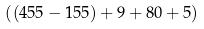<formula> <loc_0><loc_0><loc_500><loc_500>( ( 4 5 5 - 1 5 5 ) + 9 + 8 0 + 5 )</formula> 